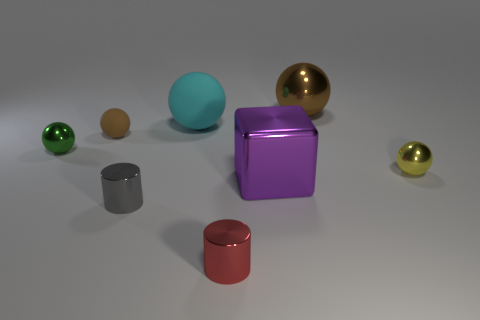Subtract all yellow balls. How many balls are left? 4 Add 1 large green metal spheres. How many objects exist? 9 Subtract all yellow spheres. How many spheres are left? 4 Subtract 2 cylinders. How many cylinders are left? 0 Subtract all spheres. How many objects are left? 3 Subtract 0 red blocks. How many objects are left? 8 Subtract all blue spheres. Subtract all gray cylinders. How many spheres are left? 5 Subtract all brown cylinders. How many brown balls are left? 2 Subtract all yellow metal spheres. Subtract all small cylinders. How many objects are left? 5 Add 5 small yellow objects. How many small yellow objects are left? 6 